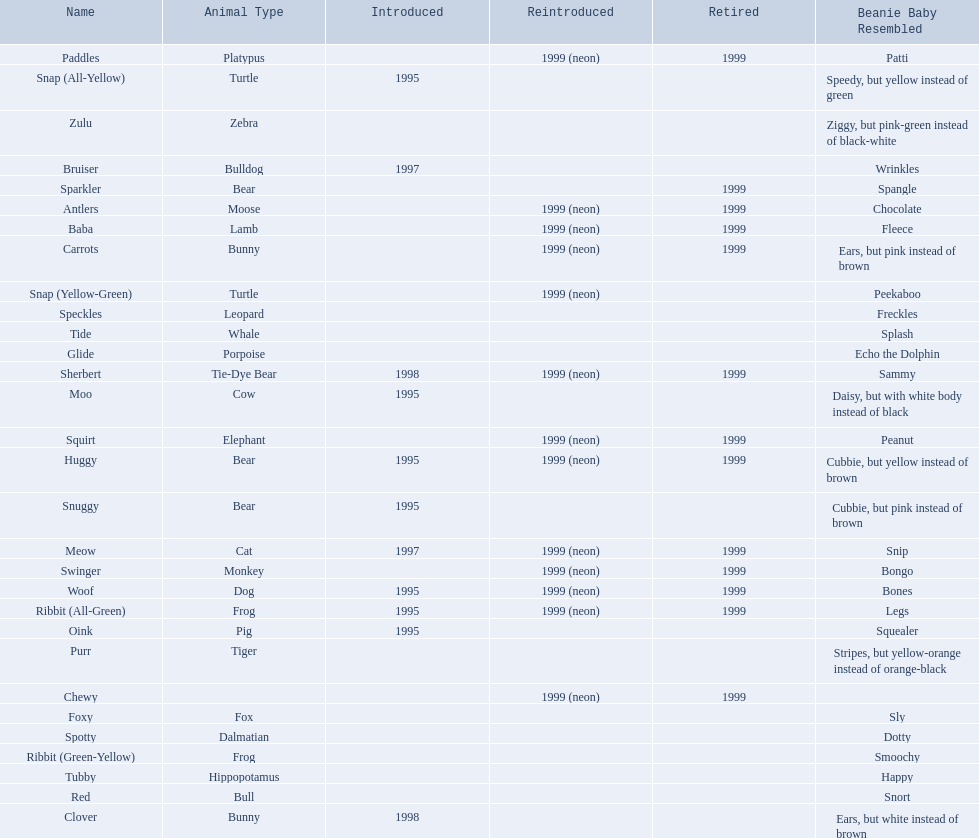What are all the pillow pals? Antlers, Baba, Bruiser, Carrots, Chewy, Clover, Foxy, Glide, Huggy, Meow, Moo, Oink, Paddles, Purr, Red, Ribbit (All-Green), Ribbit (Green-Yellow), Sherbert, Snap (All-Yellow), Snap (Yellow-Green), Snuggy, Sparkler, Speckles, Spotty, Squirt, Swinger, Tide, Tubby, Woof, Zulu. Which is the only without a listed animal type? Chewy. 